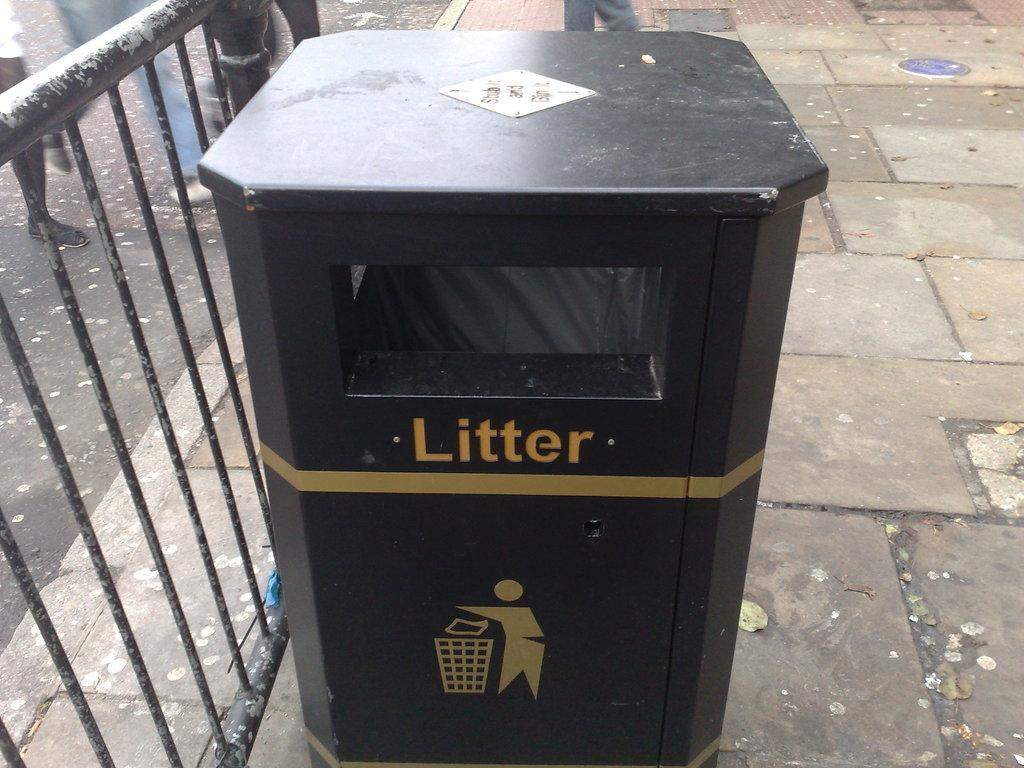<image>
Give a short and clear explanation of the subsequent image. a brown can with litter written on it is full 